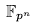<formula> <loc_0><loc_0><loc_500><loc_500>\mathbb { F } _ { p ^ { n } }</formula> 